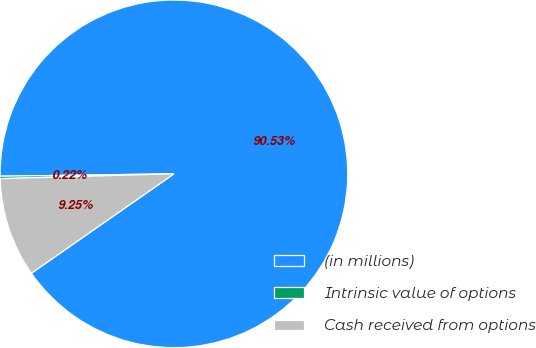Convert chart to OTSL. <chart><loc_0><loc_0><loc_500><loc_500><pie_chart><fcel>(in millions)<fcel>Intrinsic value of options<fcel>Cash received from options<nl><fcel>90.52%<fcel>0.22%<fcel>9.25%<nl></chart> 